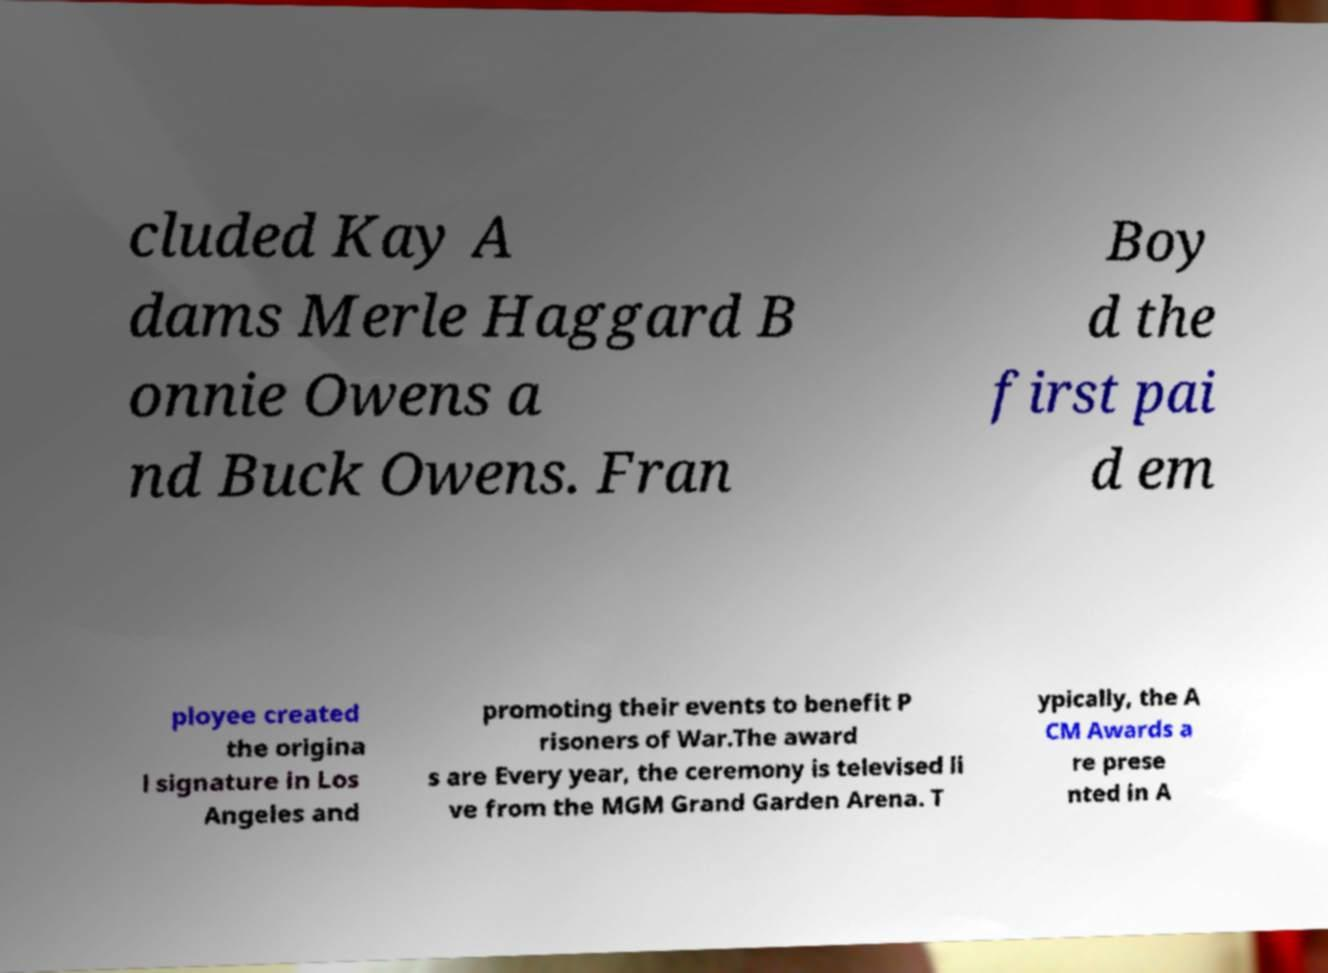There's text embedded in this image that I need extracted. Can you transcribe it verbatim? cluded Kay A dams Merle Haggard B onnie Owens a nd Buck Owens. Fran Boy d the first pai d em ployee created the origina l signature in Los Angeles and promoting their events to benefit P risoners of War.The award s are Every year, the ceremony is televised li ve from the MGM Grand Garden Arena. T ypically, the A CM Awards a re prese nted in A 